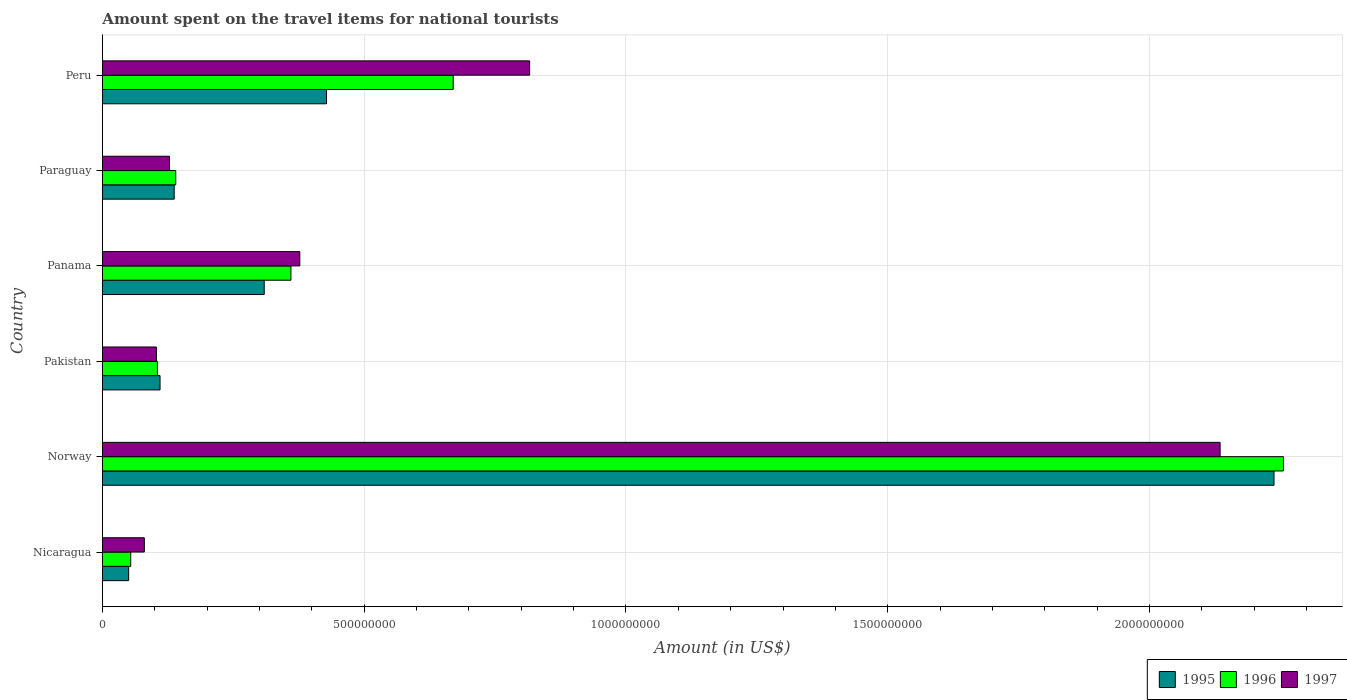How many bars are there on the 3rd tick from the bottom?
Offer a very short reply. 3. What is the label of the 3rd group of bars from the top?
Ensure brevity in your answer.  Panama. In how many cases, is the number of bars for a given country not equal to the number of legend labels?
Keep it short and to the point. 0. What is the amount spent on the travel items for national tourists in 1996 in Norway?
Offer a very short reply. 2.26e+09. Across all countries, what is the maximum amount spent on the travel items for national tourists in 1995?
Give a very brief answer. 2.24e+09. Across all countries, what is the minimum amount spent on the travel items for national tourists in 1996?
Your answer should be compact. 5.40e+07. In which country was the amount spent on the travel items for national tourists in 1997 minimum?
Give a very brief answer. Nicaragua. What is the total amount spent on the travel items for national tourists in 1997 in the graph?
Your answer should be compact. 3.64e+09. What is the difference between the amount spent on the travel items for national tourists in 1997 in Norway and that in Peru?
Offer a very short reply. 1.32e+09. What is the difference between the amount spent on the travel items for national tourists in 1996 in Peru and the amount spent on the travel items for national tourists in 1997 in Panama?
Keep it short and to the point. 2.93e+08. What is the average amount spent on the travel items for national tourists in 1997 per country?
Keep it short and to the point. 6.06e+08. What is the difference between the amount spent on the travel items for national tourists in 1997 and amount spent on the travel items for national tourists in 1996 in Peru?
Give a very brief answer. 1.46e+08. What is the ratio of the amount spent on the travel items for national tourists in 1995 in Nicaragua to that in Norway?
Offer a terse response. 0.02. Is the amount spent on the travel items for national tourists in 1996 in Panama less than that in Peru?
Your answer should be compact. Yes. What is the difference between the highest and the second highest amount spent on the travel items for national tourists in 1997?
Ensure brevity in your answer.  1.32e+09. What is the difference between the highest and the lowest amount spent on the travel items for national tourists in 1995?
Provide a succinct answer. 2.19e+09. What does the 2nd bar from the bottom in Nicaragua represents?
Ensure brevity in your answer.  1996. Is it the case that in every country, the sum of the amount spent on the travel items for national tourists in 1996 and amount spent on the travel items for national tourists in 1997 is greater than the amount spent on the travel items for national tourists in 1995?
Provide a succinct answer. Yes. Are all the bars in the graph horizontal?
Ensure brevity in your answer.  Yes. How many countries are there in the graph?
Provide a short and direct response. 6. Are the values on the major ticks of X-axis written in scientific E-notation?
Provide a succinct answer. No. Does the graph contain any zero values?
Offer a very short reply. No. Does the graph contain grids?
Your answer should be very brief. Yes. How many legend labels are there?
Make the answer very short. 3. How are the legend labels stacked?
Offer a terse response. Horizontal. What is the title of the graph?
Offer a very short reply. Amount spent on the travel items for national tourists. What is the label or title of the Y-axis?
Offer a terse response. Country. What is the Amount (in US$) of 1995 in Nicaragua?
Your answer should be compact. 5.00e+07. What is the Amount (in US$) in 1996 in Nicaragua?
Make the answer very short. 5.40e+07. What is the Amount (in US$) of 1997 in Nicaragua?
Your response must be concise. 8.00e+07. What is the Amount (in US$) of 1995 in Norway?
Offer a very short reply. 2.24e+09. What is the Amount (in US$) in 1996 in Norway?
Your response must be concise. 2.26e+09. What is the Amount (in US$) of 1997 in Norway?
Give a very brief answer. 2.14e+09. What is the Amount (in US$) of 1995 in Pakistan?
Ensure brevity in your answer.  1.10e+08. What is the Amount (in US$) in 1996 in Pakistan?
Provide a succinct answer. 1.05e+08. What is the Amount (in US$) in 1997 in Pakistan?
Provide a succinct answer. 1.03e+08. What is the Amount (in US$) in 1995 in Panama?
Offer a terse response. 3.09e+08. What is the Amount (in US$) in 1996 in Panama?
Your answer should be very brief. 3.60e+08. What is the Amount (in US$) of 1997 in Panama?
Your answer should be compact. 3.77e+08. What is the Amount (in US$) in 1995 in Paraguay?
Offer a very short reply. 1.37e+08. What is the Amount (in US$) of 1996 in Paraguay?
Keep it short and to the point. 1.40e+08. What is the Amount (in US$) of 1997 in Paraguay?
Your response must be concise. 1.28e+08. What is the Amount (in US$) in 1995 in Peru?
Offer a terse response. 4.28e+08. What is the Amount (in US$) of 1996 in Peru?
Provide a short and direct response. 6.70e+08. What is the Amount (in US$) of 1997 in Peru?
Ensure brevity in your answer.  8.16e+08. Across all countries, what is the maximum Amount (in US$) of 1995?
Offer a very short reply. 2.24e+09. Across all countries, what is the maximum Amount (in US$) of 1996?
Ensure brevity in your answer.  2.26e+09. Across all countries, what is the maximum Amount (in US$) of 1997?
Make the answer very short. 2.14e+09. Across all countries, what is the minimum Amount (in US$) of 1995?
Offer a terse response. 5.00e+07. Across all countries, what is the minimum Amount (in US$) in 1996?
Your response must be concise. 5.40e+07. Across all countries, what is the minimum Amount (in US$) in 1997?
Ensure brevity in your answer.  8.00e+07. What is the total Amount (in US$) in 1995 in the graph?
Your answer should be compact. 3.27e+09. What is the total Amount (in US$) of 1996 in the graph?
Offer a terse response. 3.58e+09. What is the total Amount (in US$) in 1997 in the graph?
Offer a terse response. 3.64e+09. What is the difference between the Amount (in US$) in 1995 in Nicaragua and that in Norway?
Your answer should be compact. -2.19e+09. What is the difference between the Amount (in US$) of 1996 in Nicaragua and that in Norway?
Keep it short and to the point. -2.20e+09. What is the difference between the Amount (in US$) of 1997 in Nicaragua and that in Norway?
Provide a succinct answer. -2.06e+09. What is the difference between the Amount (in US$) of 1995 in Nicaragua and that in Pakistan?
Provide a short and direct response. -6.00e+07. What is the difference between the Amount (in US$) of 1996 in Nicaragua and that in Pakistan?
Your answer should be compact. -5.10e+07. What is the difference between the Amount (in US$) in 1997 in Nicaragua and that in Pakistan?
Make the answer very short. -2.30e+07. What is the difference between the Amount (in US$) in 1995 in Nicaragua and that in Panama?
Your answer should be very brief. -2.59e+08. What is the difference between the Amount (in US$) of 1996 in Nicaragua and that in Panama?
Ensure brevity in your answer.  -3.06e+08. What is the difference between the Amount (in US$) of 1997 in Nicaragua and that in Panama?
Ensure brevity in your answer.  -2.97e+08. What is the difference between the Amount (in US$) of 1995 in Nicaragua and that in Paraguay?
Provide a short and direct response. -8.70e+07. What is the difference between the Amount (in US$) of 1996 in Nicaragua and that in Paraguay?
Keep it short and to the point. -8.60e+07. What is the difference between the Amount (in US$) in 1997 in Nicaragua and that in Paraguay?
Keep it short and to the point. -4.80e+07. What is the difference between the Amount (in US$) of 1995 in Nicaragua and that in Peru?
Make the answer very short. -3.78e+08. What is the difference between the Amount (in US$) of 1996 in Nicaragua and that in Peru?
Your answer should be very brief. -6.16e+08. What is the difference between the Amount (in US$) of 1997 in Nicaragua and that in Peru?
Your answer should be very brief. -7.36e+08. What is the difference between the Amount (in US$) of 1995 in Norway and that in Pakistan?
Make the answer very short. 2.13e+09. What is the difference between the Amount (in US$) of 1996 in Norway and that in Pakistan?
Your answer should be very brief. 2.15e+09. What is the difference between the Amount (in US$) of 1997 in Norway and that in Pakistan?
Keep it short and to the point. 2.03e+09. What is the difference between the Amount (in US$) of 1995 in Norway and that in Panama?
Make the answer very short. 1.93e+09. What is the difference between the Amount (in US$) in 1996 in Norway and that in Panama?
Make the answer very short. 1.90e+09. What is the difference between the Amount (in US$) of 1997 in Norway and that in Panama?
Offer a very short reply. 1.76e+09. What is the difference between the Amount (in US$) in 1995 in Norway and that in Paraguay?
Provide a succinct answer. 2.10e+09. What is the difference between the Amount (in US$) in 1996 in Norway and that in Paraguay?
Your answer should be compact. 2.12e+09. What is the difference between the Amount (in US$) of 1997 in Norway and that in Paraguay?
Ensure brevity in your answer.  2.01e+09. What is the difference between the Amount (in US$) of 1995 in Norway and that in Peru?
Your answer should be compact. 1.81e+09. What is the difference between the Amount (in US$) of 1996 in Norway and that in Peru?
Your answer should be very brief. 1.59e+09. What is the difference between the Amount (in US$) in 1997 in Norway and that in Peru?
Ensure brevity in your answer.  1.32e+09. What is the difference between the Amount (in US$) of 1995 in Pakistan and that in Panama?
Your answer should be very brief. -1.99e+08. What is the difference between the Amount (in US$) of 1996 in Pakistan and that in Panama?
Your answer should be very brief. -2.55e+08. What is the difference between the Amount (in US$) of 1997 in Pakistan and that in Panama?
Provide a succinct answer. -2.74e+08. What is the difference between the Amount (in US$) of 1995 in Pakistan and that in Paraguay?
Keep it short and to the point. -2.70e+07. What is the difference between the Amount (in US$) of 1996 in Pakistan and that in Paraguay?
Offer a terse response. -3.50e+07. What is the difference between the Amount (in US$) of 1997 in Pakistan and that in Paraguay?
Provide a short and direct response. -2.50e+07. What is the difference between the Amount (in US$) of 1995 in Pakistan and that in Peru?
Provide a short and direct response. -3.18e+08. What is the difference between the Amount (in US$) in 1996 in Pakistan and that in Peru?
Offer a terse response. -5.65e+08. What is the difference between the Amount (in US$) in 1997 in Pakistan and that in Peru?
Your answer should be compact. -7.13e+08. What is the difference between the Amount (in US$) of 1995 in Panama and that in Paraguay?
Your answer should be compact. 1.72e+08. What is the difference between the Amount (in US$) of 1996 in Panama and that in Paraguay?
Keep it short and to the point. 2.20e+08. What is the difference between the Amount (in US$) of 1997 in Panama and that in Paraguay?
Offer a terse response. 2.49e+08. What is the difference between the Amount (in US$) of 1995 in Panama and that in Peru?
Give a very brief answer. -1.19e+08. What is the difference between the Amount (in US$) of 1996 in Panama and that in Peru?
Keep it short and to the point. -3.10e+08. What is the difference between the Amount (in US$) in 1997 in Panama and that in Peru?
Ensure brevity in your answer.  -4.39e+08. What is the difference between the Amount (in US$) in 1995 in Paraguay and that in Peru?
Keep it short and to the point. -2.91e+08. What is the difference between the Amount (in US$) of 1996 in Paraguay and that in Peru?
Ensure brevity in your answer.  -5.30e+08. What is the difference between the Amount (in US$) in 1997 in Paraguay and that in Peru?
Offer a terse response. -6.88e+08. What is the difference between the Amount (in US$) in 1995 in Nicaragua and the Amount (in US$) in 1996 in Norway?
Keep it short and to the point. -2.21e+09. What is the difference between the Amount (in US$) of 1995 in Nicaragua and the Amount (in US$) of 1997 in Norway?
Make the answer very short. -2.08e+09. What is the difference between the Amount (in US$) of 1996 in Nicaragua and the Amount (in US$) of 1997 in Norway?
Give a very brief answer. -2.08e+09. What is the difference between the Amount (in US$) of 1995 in Nicaragua and the Amount (in US$) of 1996 in Pakistan?
Keep it short and to the point. -5.50e+07. What is the difference between the Amount (in US$) of 1995 in Nicaragua and the Amount (in US$) of 1997 in Pakistan?
Keep it short and to the point. -5.30e+07. What is the difference between the Amount (in US$) of 1996 in Nicaragua and the Amount (in US$) of 1997 in Pakistan?
Keep it short and to the point. -4.90e+07. What is the difference between the Amount (in US$) in 1995 in Nicaragua and the Amount (in US$) in 1996 in Panama?
Provide a short and direct response. -3.10e+08. What is the difference between the Amount (in US$) of 1995 in Nicaragua and the Amount (in US$) of 1997 in Panama?
Keep it short and to the point. -3.27e+08. What is the difference between the Amount (in US$) in 1996 in Nicaragua and the Amount (in US$) in 1997 in Panama?
Your answer should be very brief. -3.23e+08. What is the difference between the Amount (in US$) in 1995 in Nicaragua and the Amount (in US$) in 1996 in Paraguay?
Offer a terse response. -9.00e+07. What is the difference between the Amount (in US$) of 1995 in Nicaragua and the Amount (in US$) of 1997 in Paraguay?
Ensure brevity in your answer.  -7.80e+07. What is the difference between the Amount (in US$) in 1996 in Nicaragua and the Amount (in US$) in 1997 in Paraguay?
Your answer should be compact. -7.40e+07. What is the difference between the Amount (in US$) of 1995 in Nicaragua and the Amount (in US$) of 1996 in Peru?
Your response must be concise. -6.20e+08. What is the difference between the Amount (in US$) of 1995 in Nicaragua and the Amount (in US$) of 1997 in Peru?
Your answer should be compact. -7.66e+08. What is the difference between the Amount (in US$) in 1996 in Nicaragua and the Amount (in US$) in 1997 in Peru?
Provide a short and direct response. -7.62e+08. What is the difference between the Amount (in US$) of 1995 in Norway and the Amount (in US$) of 1996 in Pakistan?
Your answer should be very brief. 2.13e+09. What is the difference between the Amount (in US$) in 1995 in Norway and the Amount (in US$) in 1997 in Pakistan?
Offer a very short reply. 2.14e+09. What is the difference between the Amount (in US$) of 1996 in Norway and the Amount (in US$) of 1997 in Pakistan?
Ensure brevity in your answer.  2.15e+09. What is the difference between the Amount (in US$) in 1995 in Norway and the Amount (in US$) in 1996 in Panama?
Make the answer very short. 1.88e+09. What is the difference between the Amount (in US$) in 1995 in Norway and the Amount (in US$) in 1997 in Panama?
Offer a terse response. 1.86e+09. What is the difference between the Amount (in US$) of 1996 in Norway and the Amount (in US$) of 1997 in Panama?
Make the answer very short. 1.88e+09. What is the difference between the Amount (in US$) of 1995 in Norway and the Amount (in US$) of 1996 in Paraguay?
Provide a short and direct response. 2.10e+09. What is the difference between the Amount (in US$) in 1995 in Norway and the Amount (in US$) in 1997 in Paraguay?
Give a very brief answer. 2.11e+09. What is the difference between the Amount (in US$) in 1996 in Norway and the Amount (in US$) in 1997 in Paraguay?
Your answer should be very brief. 2.13e+09. What is the difference between the Amount (in US$) in 1995 in Norway and the Amount (in US$) in 1996 in Peru?
Keep it short and to the point. 1.57e+09. What is the difference between the Amount (in US$) in 1995 in Norway and the Amount (in US$) in 1997 in Peru?
Your answer should be very brief. 1.42e+09. What is the difference between the Amount (in US$) of 1996 in Norway and the Amount (in US$) of 1997 in Peru?
Offer a very short reply. 1.44e+09. What is the difference between the Amount (in US$) of 1995 in Pakistan and the Amount (in US$) of 1996 in Panama?
Your response must be concise. -2.50e+08. What is the difference between the Amount (in US$) of 1995 in Pakistan and the Amount (in US$) of 1997 in Panama?
Your answer should be very brief. -2.67e+08. What is the difference between the Amount (in US$) in 1996 in Pakistan and the Amount (in US$) in 1997 in Panama?
Give a very brief answer. -2.72e+08. What is the difference between the Amount (in US$) in 1995 in Pakistan and the Amount (in US$) in 1996 in Paraguay?
Offer a terse response. -3.00e+07. What is the difference between the Amount (in US$) of 1995 in Pakistan and the Amount (in US$) of 1997 in Paraguay?
Keep it short and to the point. -1.80e+07. What is the difference between the Amount (in US$) of 1996 in Pakistan and the Amount (in US$) of 1997 in Paraguay?
Ensure brevity in your answer.  -2.30e+07. What is the difference between the Amount (in US$) in 1995 in Pakistan and the Amount (in US$) in 1996 in Peru?
Give a very brief answer. -5.60e+08. What is the difference between the Amount (in US$) of 1995 in Pakistan and the Amount (in US$) of 1997 in Peru?
Make the answer very short. -7.06e+08. What is the difference between the Amount (in US$) in 1996 in Pakistan and the Amount (in US$) in 1997 in Peru?
Provide a succinct answer. -7.11e+08. What is the difference between the Amount (in US$) of 1995 in Panama and the Amount (in US$) of 1996 in Paraguay?
Offer a very short reply. 1.69e+08. What is the difference between the Amount (in US$) in 1995 in Panama and the Amount (in US$) in 1997 in Paraguay?
Your response must be concise. 1.81e+08. What is the difference between the Amount (in US$) in 1996 in Panama and the Amount (in US$) in 1997 in Paraguay?
Keep it short and to the point. 2.32e+08. What is the difference between the Amount (in US$) of 1995 in Panama and the Amount (in US$) of 1996 in Peru?
Your response must be concise. -3.61e+08. What is the difference between the Amount (in US$) in 1995 in Panama and the Amount (in US$) in 1997 in Peru?
Make the answer very short. -5.07e+08. What is the difference between the Amount (in US$) in 1996 in Panama and the Amount (in US$) in 1997 in Peru?
Provide a succinct answer. -4.56e+08. What is the difference between the Amount (in US$) of 1995 in Paraguay and the Amount (in US$) of 1996 in Peru?
Your answer should be compact. -5.33e+08. What is the difference between the Amount (in US$) of 1995 in Paraguay and the Amount (in US$) of 1997 in Peru?
Offer a very short reply. -6.79e+08. What is the difference between the Amount (in US$) of 1996 in Paraguay and the Amount (in US$) of 1997 in Peru?
Make the answer very short. -6.76e+08. What is the average Amount (in US$) in 1995 per country?
Give a very brief answer. 5.45e+08. What is the average Amount (in US$) of 1996 per country?
Make the answer very short. 5.98e+08. What is the average Amount (in US$) of 1997 per country?
Give a very brief answer. 6.06e+08. What is the difference between the Amount (in US$) of 1995 and Amount (in US$) of 1997 in Nicaragua?
Keep it short and to the point. -3.00e+07. What is the difference between the Amount (in US$) in 1996 and Amount (in US$) in 1997 in Nicaragua?
Your answer should be compact. -2.60e+07. What is the difference between the Amount (in US$) of 1995 and Amount (in US$) of 1996 in Norway?
Provide a succinct answer. -1.80e+07. What is the difference between the Amount (in US$) of 1995 and Amount (in US$) of 1997 in Norway?
Make the answer very short. 1.03e+08. What is the difference between the Amount (in US$) in 1996 and Amount (in US$) in 1997 in Norway?
Make the answer very short. 1.21e+08. What is the difference between the Amount (in US$) in 1995 and Amount (in US$) in 1997 in Pakistan?
Make the answer very short. 7.00e+06. What is the difference between the Amount (in US$) in 1996 and Amount (in US$) in 1997 in Pakistan?
Your answer should be compact. 2.00e+06. What is the difference between the Amount (in US$) of 1995 and Amount (in US$) of 1996 in Panama?
Give a very brief answer. -5.10e+07. What is the difference between the Amount (in US$) of 1995 and Amount (in US$) of 1997 in Panama?
Keep it short and to the point. -6.80e+07. What is the difference between the Amount (in US$) in 1996 and Amount (in US$) in 1997 in Panama?
Make the answer very short. -1.70e+07. What is the difference between the Amount (in US$) of 1995 and Amount (in US$) of 1997 in Paraguay?
Keep it short and to the point. 9.00e+06. What is the difference between the Amount (in US$) in 1996 and Amount (in US$) in 1997 in Paraguay?
Keep it short and to the point. 1.20e+07. What is the difference between the Amount (in US$) of 1995 and Amount (in US$) of 1996 in Peru?
Your answer should be very brief. -2.42e+08. What is the difference between the Amount (in US$) of 1995 and Amount (in US$) of 1997 in Peru?
Your answer should be very brief. -3.88e+08. What is the difference between the Amount (in US$) in 1996 and Amount (in US$) in 1997 in Peru?
Keep it short and to the point. -1.46e+08. What is the ratio of the Amount (in US$) in 1995 in Nicaragua to that in Norway?
Provide a succinct answer. 0.02. What is the ratio of the Amount (in US$) in 1996 in Nicaragua to that in Norway?
Ensure brevity in your answer.  0.02. What is the ratio of the Amount (in US$) in 1997 in Nicaragua to that in Norway?
Make the answer very short. 0.04. What is the ratio of the Amount (in US$) of 1995 in Nicaragua to that in Pakistan?
Offer a terse response. 0.45. What is the ratio of the Amount (in US$) in 1996 in Nicaragua to that in Pakistan?
Your answer should be very brief. 0.51. What is the ratio of the Amount (in US$) of 1997 in Nicaragua to that in Pakistan?
Your response must be concise. 0.78. What is the ratio of the Amount (in US$) in 1995 in Nicaragua to that in Panama?
Offer a very short reply. 0.16. What is the ratio of the Amount (in US$) of 1996 in Nicaragua to that in Panama?
Keep it short and to the point. 0.15. What is the ratio of the Amount (in US$) of 1997 in Nicaragua to that in Panama?
Give a very brief answer. 0.21. What is the ratio of the Amount (in US$) in 1995 in Nicaragua to that in Paraguay?
Provide a short and direct response. 0.36. What is the ratio of the Amount (in US$) of 1996 in Nicaragua to that in Paraguay?
Your answer should be compact. 0.39. What is the ratio of the Amount (in US$) of 1995 in Nicaragua to that in Peru?
Keep it short and to the point. 0.12. What is the ratio of the Amount (in US$) in 1996 in Nicaragua to that in Peru?
Your answer should be very brief. 0.08. What is the ratio of the Amount (in US$) of 1997 in Nicaragua to that in Peru?
Your answer should be very brief. 0.1. What is the ratio of the Amount (in US$) of 1995 in Norway to that in Pakistan?
Provide a short and direct response. 20.35. What is the ratio of the Amount (in US$) in 1996 in Norway to that in Pakistan?
Your answer should be very brief. 21.49. What is the ratio of the Amount (in US$) in 1997 in Norway to that in Pakistan?
Provide a succinct answer. 20.73. What is the ratio of the Amount (in US$) in 1995 in Norway to that in Panama?
Your response must be concise. 7.24. What is the ratio of the Amount (in US$) of 1996 in Norway to that in Panama?
Your answer should be compact. 6.27. What is the ratio of the Amount (in US$) of 1997 in Norway to that in Panama?
Your answer should be compact. 5.66. What is the ratio of the Amount (in US$) in 1995 in Norway to that in Paraguay?
Make the answer very short. 16.34. What is the ratio of the Amount (in US$) in 1996 in Norway to that in Paraguay?
Ensure brevity in your answer.  16.11. What is the ratio of the Amount (in US$) of 1997 in Norway to that in Paraguay?
Offer a very short reply. 16.68. What is the ratio of the Amount (in US$) of 1995 in Norway to that in Peru?
Ensure brevity in your answer.  5.23. What is the ratio of the Amount (in US$) in 1996 in Norway to that in Peru?
Provide a short and direct response. 3.37. What is the ratio of the Amount (in US$) in 1997 in Norway to that in Peru?
Provide a succinct answer. 2.62. What is the ratio of the Amount (in US$) of 1995 in Pakistan to that in Panama?
Make the answer very short. 0.36. What is the ratio of the Amount (in US$) in 1996 in Pakistan to that in Panama?
Provide a succinct answer. 0.29. What is the ratio of the Amount (in US$) in 1997 in Pakistan to that in Panama?
Your answer should be very brief. 0.27. What is the ratio of the Amount (in US$) of 1995 in Pakistan to that in Paraguay?
Provide a short and direct response. 0.8. What is the ratio of the Amount (in US$) in 1997 in Pakistan to that in Paraguay?
Your answer should be very brief. 0.8. What is the ratio of the Amount (in US$) of 1995 in Pakistan to that in Peru?
Your answer should be compact. 0.26. What is the ratio of the Amount (in US$) of 1996 in Pakistan to that in Peru?
Your answer should be compact. 0.16. What is the ratio of the Amount (in US$) of 1997 in Pakistan to that in Peru?
Your response must be concise. 0.13. What is the ratio of the Amount (in US$) of 1995 in Panama to that in Paraguay?
Your answer should be very brief. 2.26. What is the ratio of the Amount (in US$) of 1996 in Panama to that in Paraguay?
Give a very brief answer. 2.57. What is the ratio of the Amount (in US$) in 1997 in Panama to that in Paraguay?
Keep it short and to the point. 2.95. What is the ratio of the Amount (in US$) of 1995 in Panama to that in Peru?
Keep it short and to the point. 0.72. What is the ratio of the Amount (in US$) in 1996 in Panama to that in Peru?
Your answer should be very brief. 0.54. What is the ratio of the Amount (in US$) in 1997 in Panama to that in Peru?
Keep it short and to the point. 0.46. What is the ratio of the Amount (in US$) of 1995 in Paraguay to that in Peru?
Make the answer very short. 0.32. What is the ratio of the Amount (in US$) of 1996 in Paraguay to that in Peru?
Ensure brevity in your answer.  0.21. What is the ratio of the Amount (in US$) of 1997 in Paraguay to that in Peru?
Your response must be concise. 0.16. What is the difference between the highest and the second highest Amount (in US$) in 1995?
Ensure brevity in your answer.  1.81e+09. What is the difference between the highest and the second highest Amount (in US$) in 1996?
Ensure brevity in your answer.  1.59e+09. What is the difference between the highest and the second highest Amount (in US$) of 1997?
Your answer should be very brief. 1.32e+09. What is the difference between the highest and the lowest Amount (in US$) of 1995?
Offer a very short reply. 2.19e+09. What is the difference between the highest and the lowest Amount (in US$) in 1996?
Your response must be concise. 2.20e+09. What is the difference between the highest and the lowest Amount (in US$) of 1997?
Provide a succinct answer. 2.06e+09. 